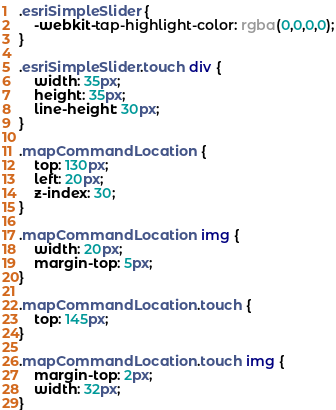Convert code to text. <code><loc_0><loc_0><loc_500><loc_500><_CSS_>.esriSimpleSlider {
	-webkit-tap-highlight-color: rgba(0,0,0,0);
}

.esriSimpleSlider.touch div {
	width: 35px;
	height: 35px;
	line-height: 30px;
}

.mapCommandLocation {
	top: 130px;
	left: 20px;
	z-index: 30;
}

.mapCommandLocation img {
	width: 20px;
	margin-top: 5px;
}

.mapCommandLocation.touch {
	top: 145px;
}

.mapCommandLocation.touch img {
	margin-top: 2px;
	width: 32px;
}</code> 